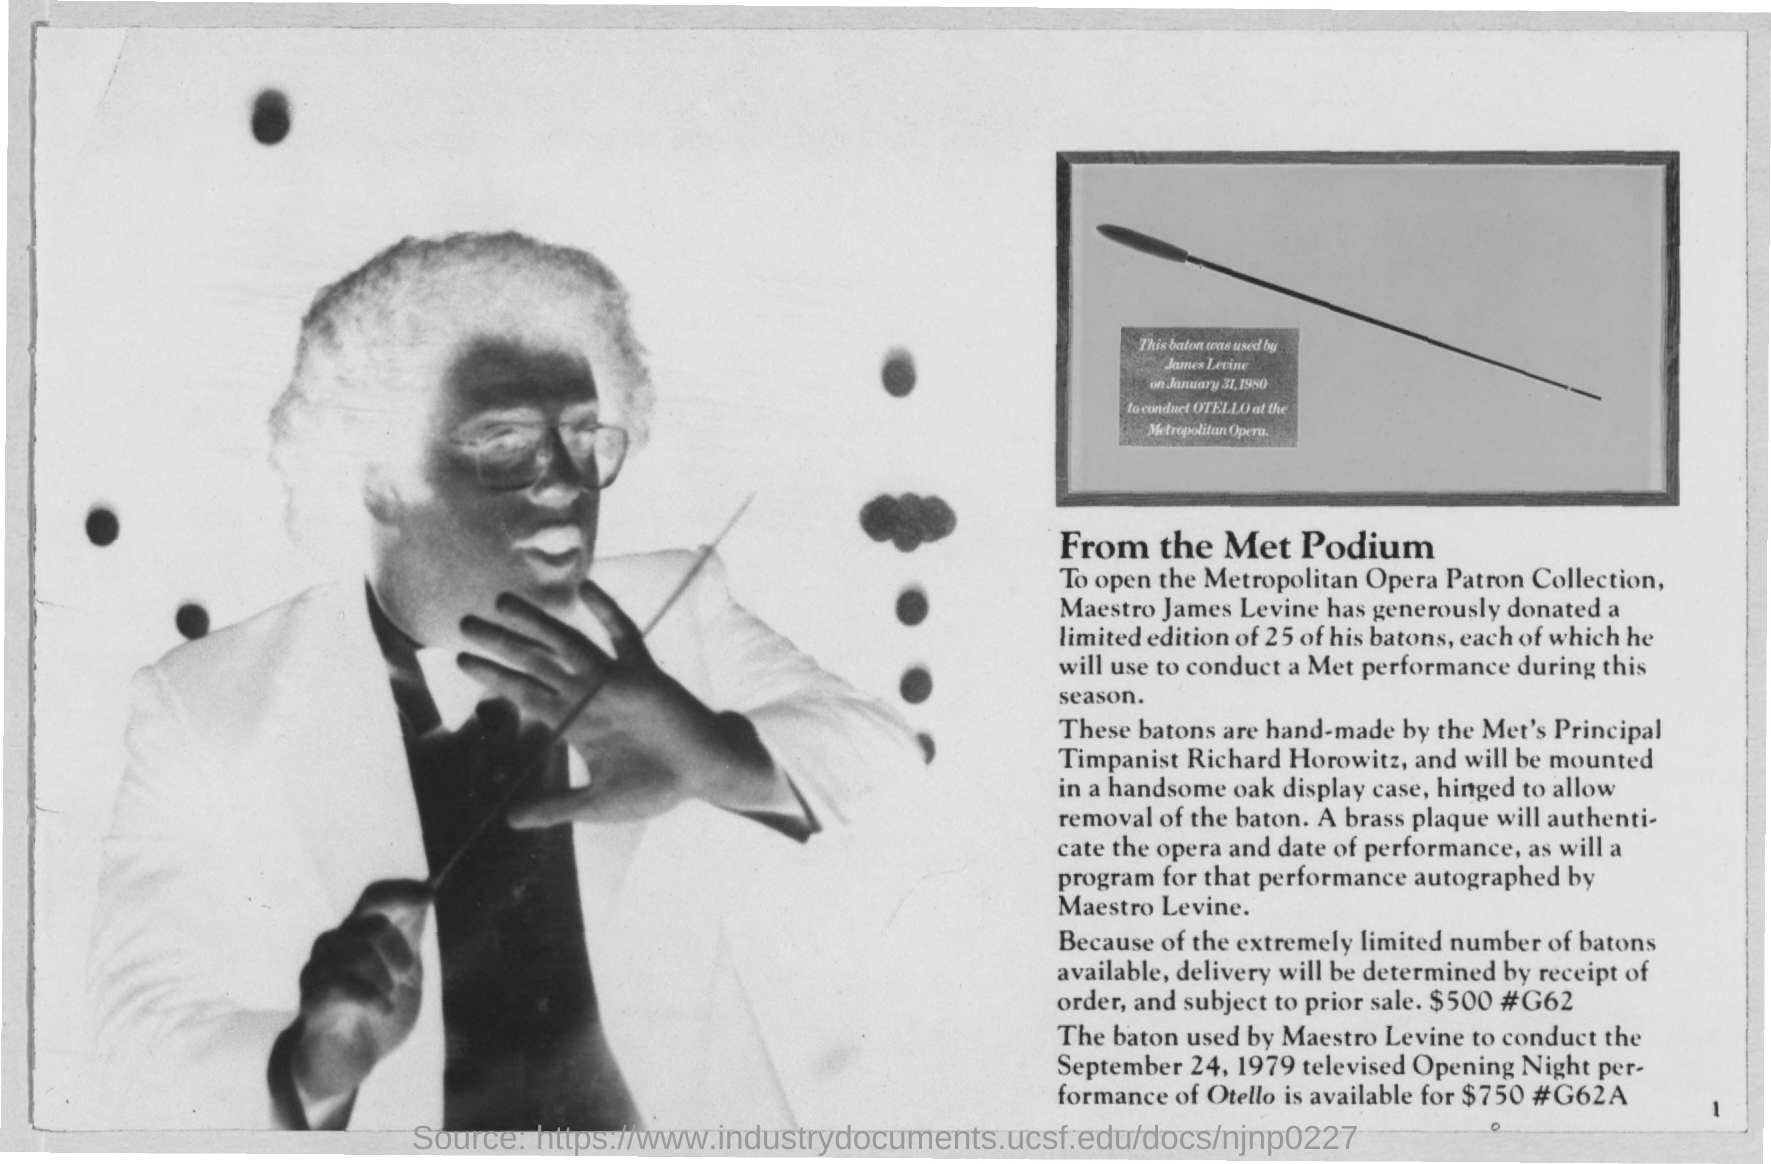Whos is Met's Principal Timpanist?
Give a very brief answer. Richard Horowitz. What is the Price of the baton used by Maestro Levine?
Offer a terse response. $750. 